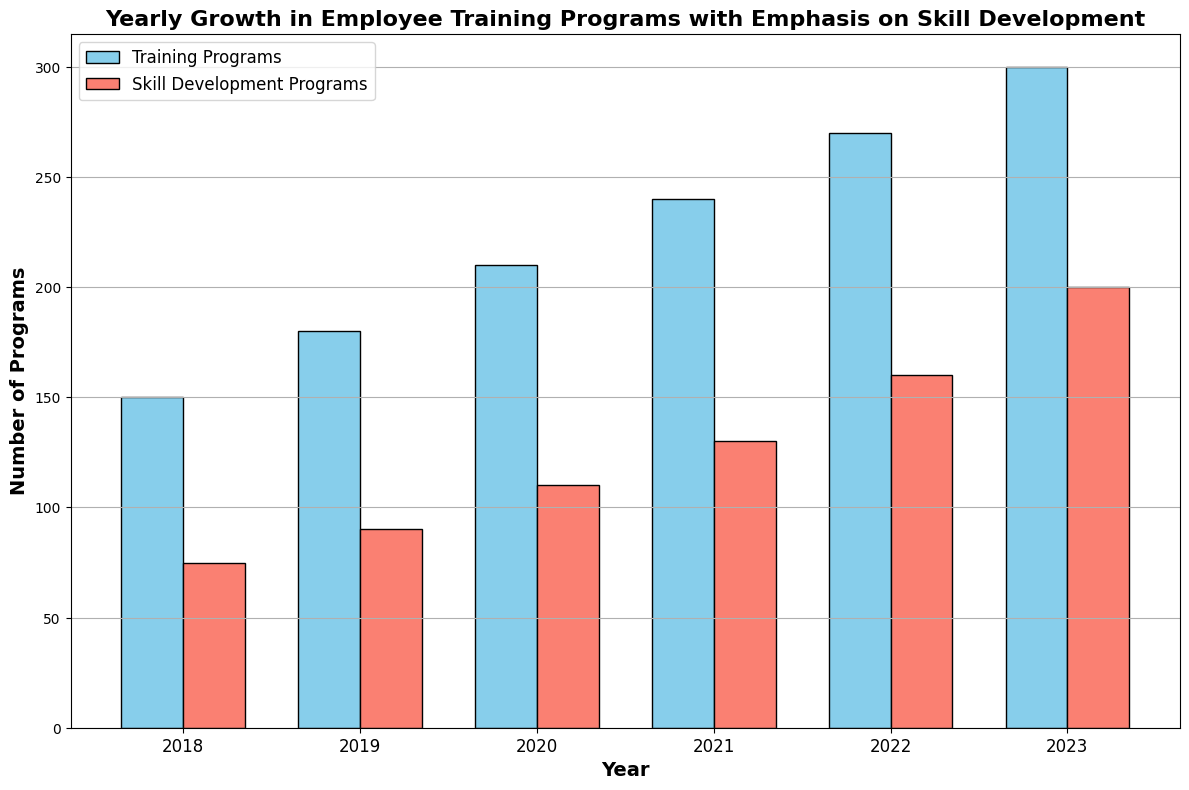What is the total number of Training Programs and Skill Development Programs in 2021? Adding the number of Training Programs and Skill Development Programs in 2021, we get 240 (Training Programs) + 130 (Skill Development Programs) = 370
Answer: 370 Did the number of Skill Development Programs increase or decrease from 2020 to 2021? Comparing the number of Skill Development Programs from 2020 (110) to 2021 (130), we see an increase by 20.
Answer: Increase What was the difference between Training Programs and Skill Development Programs in 2023? Subtracting the number of Skill Development Programs in 2023 (200) from the number of Training Programs in 2023 (300), we get 300 - 200 = 100
Answer: 100 Which year had the smallest gap between Training Programs and Skill Development Programs? The gaps are: 2018 (75), 2019 (90), 2020 (100), 2021 (110), 2022 (110), 2023 (100). The smallest gap is in 2018 with a gap of 75.
Answer: 2018 How many Training Programs were introduced in total from 2019 to 2023? Summing the number of Training Programs from 2019 (180), 2020 (210), 2021 (240), 2022 (270), 2023 (300), we get 180 + 210 + 240 + 270 + 300 = 1200
Answer: 1200 In which year did the Skill Development Programs surpass the 100 mark? Checking the data for Skill Development Programs: 2018 (75), 2019 (90), 2020 (110), we see that the number surpasses 100 in 2020.
Answer: 2020 Compare the growth in the number of Training Programs between 2019 and 2020 with the growth between 2022 and 2023. Which period had higher growth? Growth from 2019 to 2020: 210 - 180 = 30. Growth from 2022 to 2023: 300 - 270 = 30. Both periods had a growth of 30.
Answer: Both are equal What is the average number of Skill Development Programs from 2018 to 2023? Summing the Skill Development Programs from 2018 to 2023 and dividing by the number of years, (75 + 90 + 110 + 130 + 160 + 200) / 6 = 765 / 6 = 127.5
Answer: 127.5 Which color represents the Skill Development Programs in the bar chart? Observing the bar chart, the bars representing Skill Development Programs are colored in salmon.
Answer: Salmon 